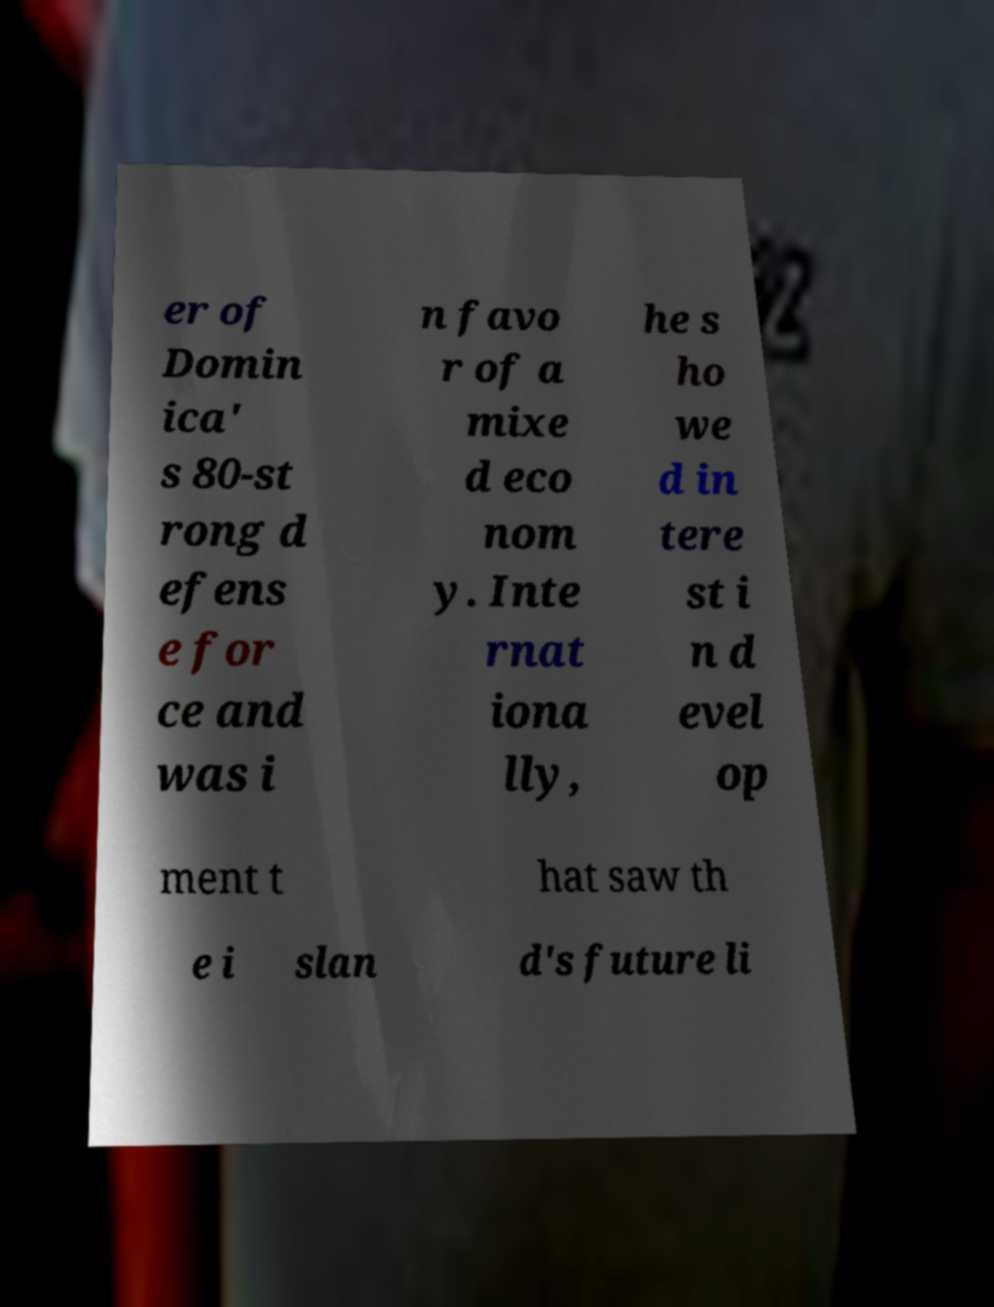Please read and relay the text visible in this image. What does it say? er of Domin ica' s 80-st rong d efens e for ce and was i n favo r of a mixe d eco nom y. Inte rnat iona lly, he s ho we d in tere st i n d evel op ment t hat saw th e i slan d's future li 